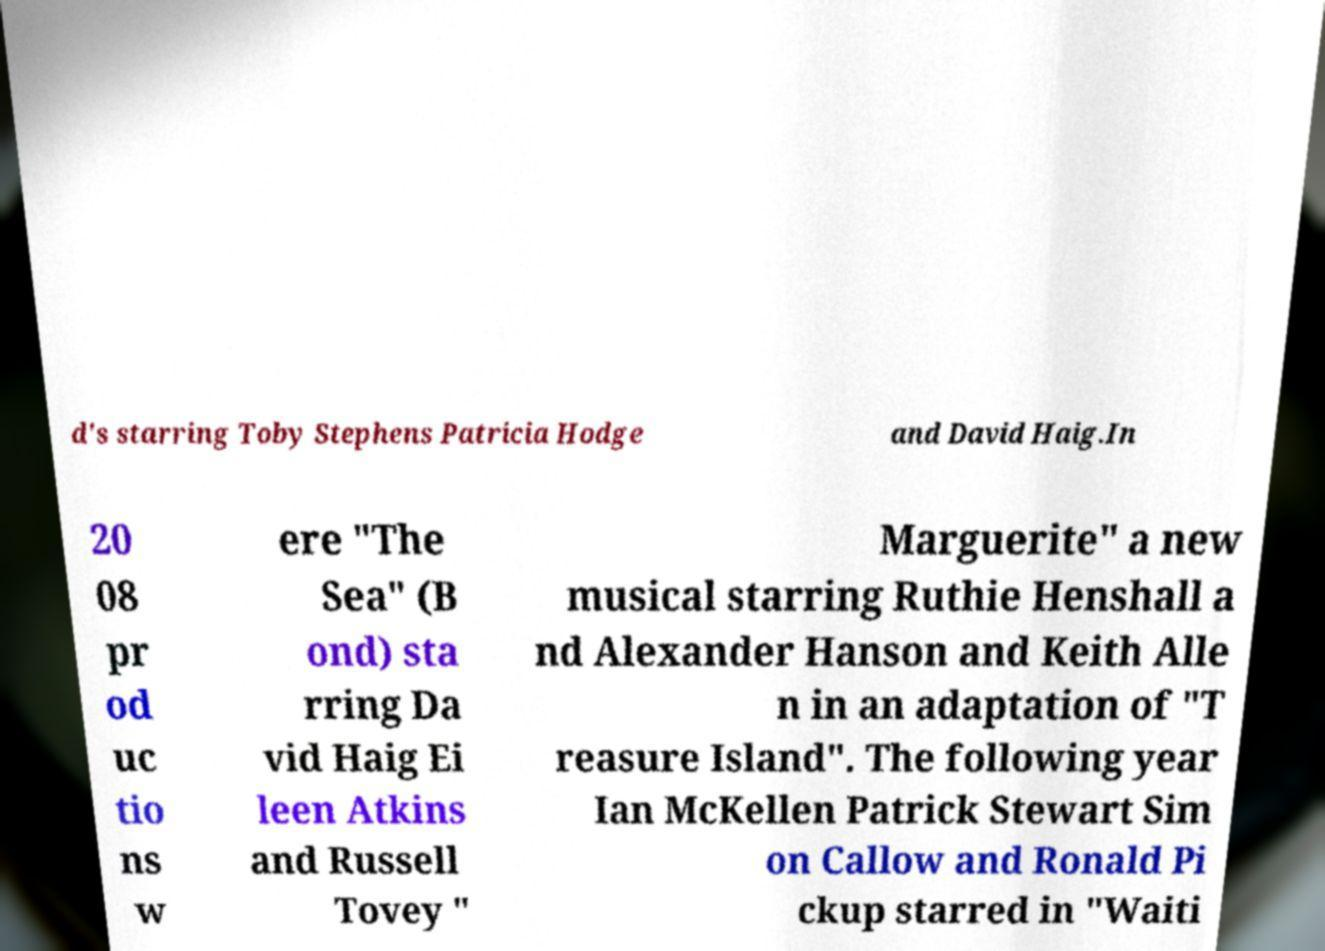Could you extract and type out the text from this image? d's starring Toby Stephens Patricia Hodge and David Haig.In 20 08 pr od uc tio ns w ere "The Sea" (B ond) sta rring Da vid Haig Ei leen Atkins and Russell Tovey " Marguerite" a new musical starring Ruthie Henshall a nd Alexander Hanson and Keith Alle n in an adaptation of "T reasure Island". The following year Ian McKellen Patrick Stewart Sim on Callow and Ronald Pi ckup starred in "Waiti 